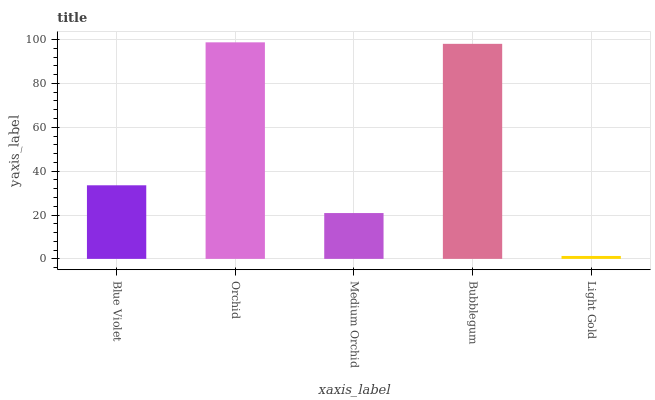Is Light Gold the minimum?
Answer yes or no. Yes. Is Orchid the maximum?
Answer yes or no. Yes. Is Medium Orchid the minimum?
Answer yes or no. No. Is Medium Orchid the maximum?
Answer yes or no. No. Is Orchid greater than Medium Orchid?
Answer yes or no. Yes. Is Medium Orchid less than Orchid?
Answer yes or no. Yes. Is Medium Orchid greater than Orchid?
Answer yes or no. No. Is Orchid less than Medium Orchid?
Answer yes or no. No. Is Blue Violet the high median?
Answer yes or no. Yes. Is Blue Violet the low median?
Answer yes or no. Yes. Is Bubblegum the high median?
Answer yes or no. No. Is Orchid the low median?
Answer yes or no. No. 